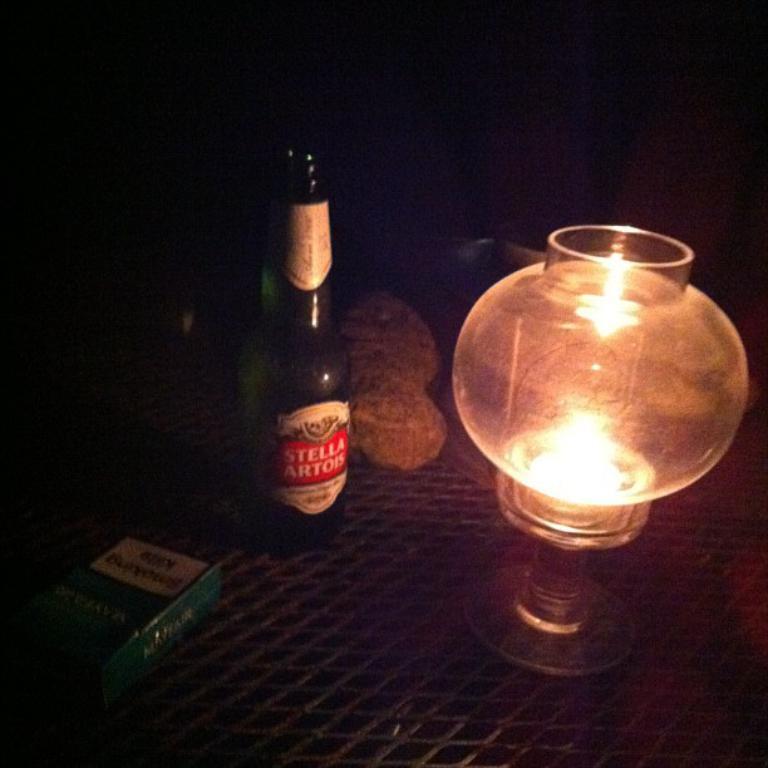What is the name of the beer brand?
Keep it short and to the point. Stella artois. 